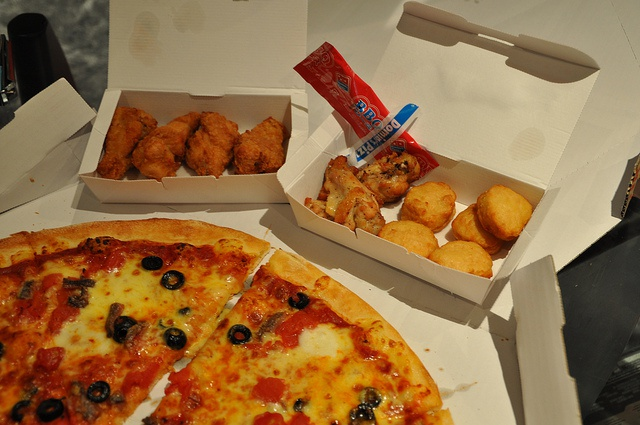Describe the objects in this image and their specific colors. I can see a pizza in black, red, maroon, and orange tones in this image. 